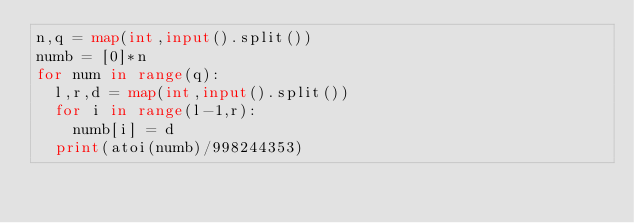<code> <loc_0><loc_0><loc_500><loc_500><_Python_>n,q = map(int,input().split())
numb = [0]*n
for num in range(q):
  l,r,d = map(int,input().split())
  for i in range(l-1,r):
    numb[i] = d
  print(atoi(numb)/998244353)
  </code> 